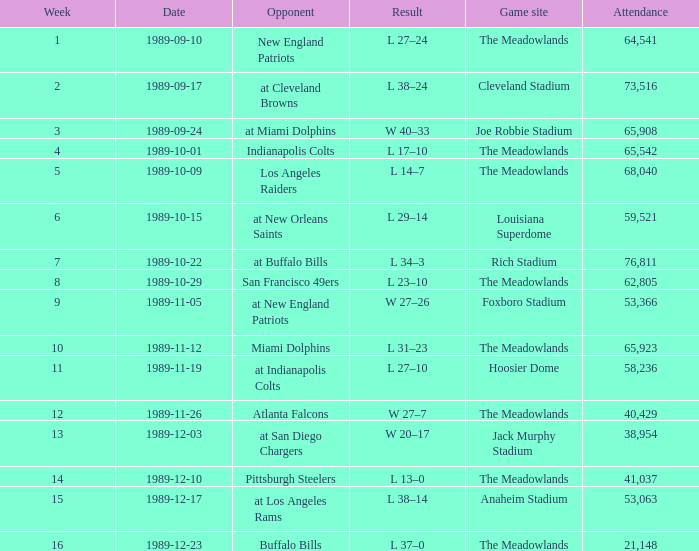What day did they play before week 2? 1989-09-10. 